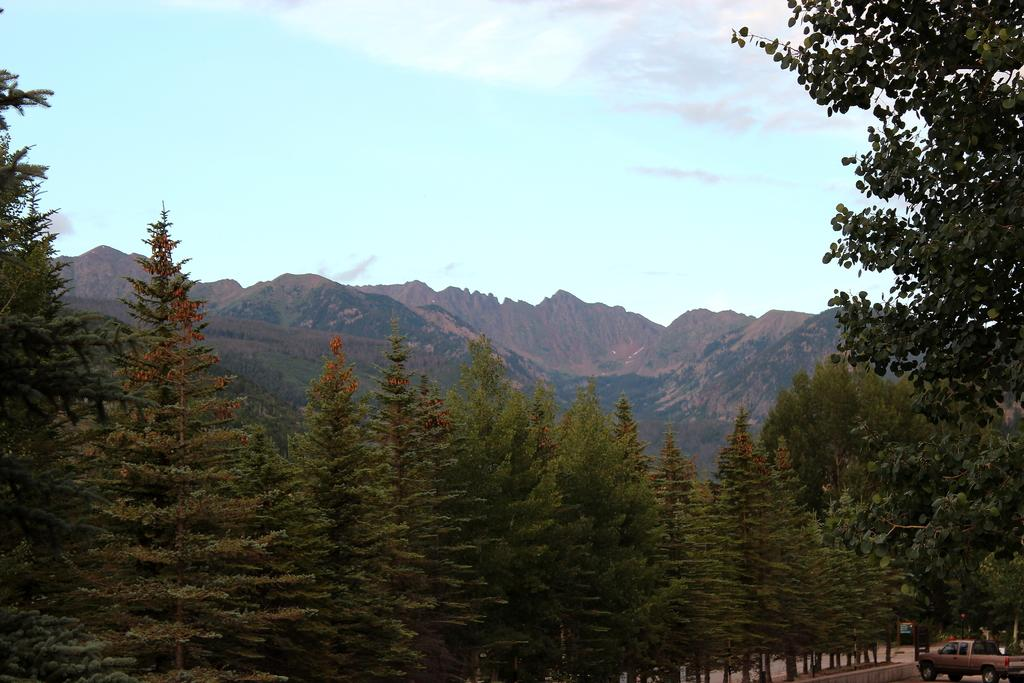What is the main subject of the image? There is a vehicle in the image. What is located behind the vehicle? There is a board behind the vehicle. What type of natural features can be seen in the image? There are trees and hills visible in the image. What is visible in the background of the image? The sky is visible in the image. Where is the basin located in the image? There is no basin present in the image. What color is the egg in the image? There is no egg present in the image. 